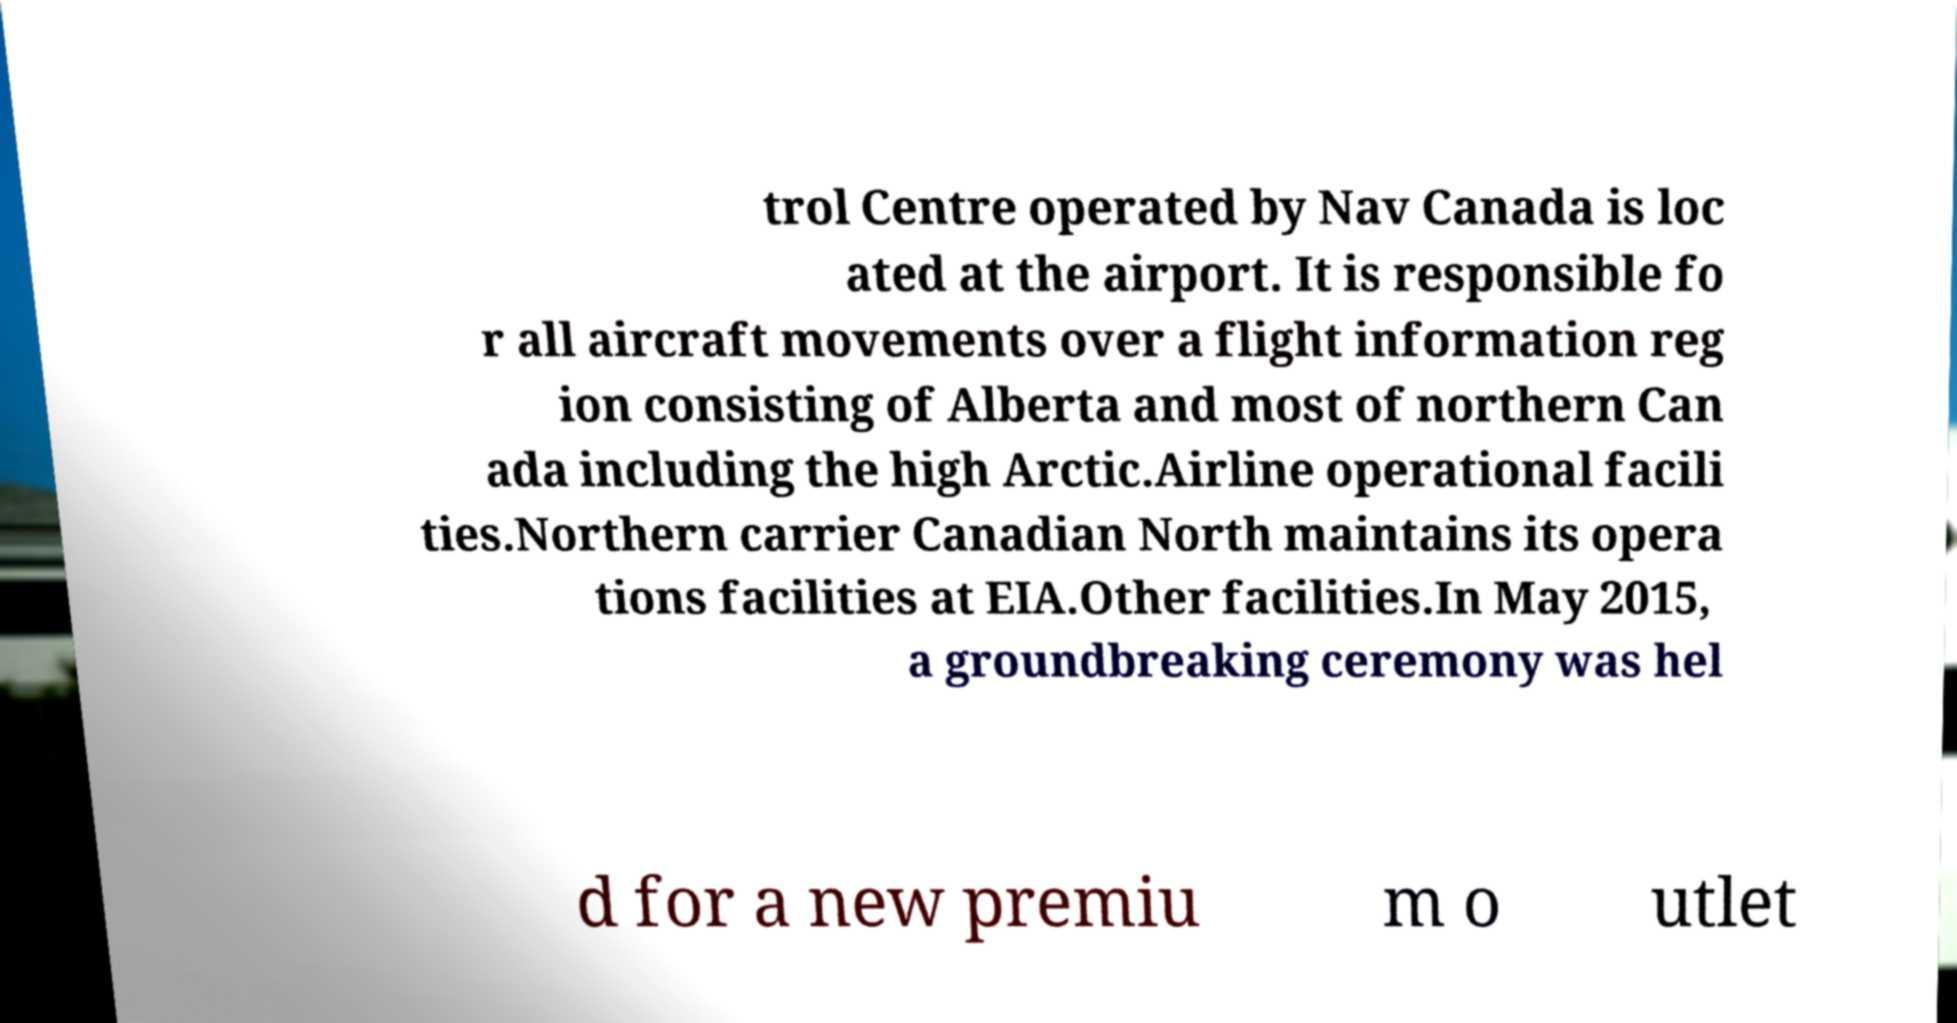Please identify and transcribe the text found in this image. trol Centre operated by Nav Canada is loc ated at the airport. It is responsible fo r all aircraft movements over a flight information reg ion consisting of Alberta and most of northern Can ada including the high Arctic.Airline operational facili ties.Northern carrier Canadian North maintains its opera tions facilities at EIA.Other facilities.In May 2015, a groundbreaking ceremony was hel d for a new premiu m o utlet 